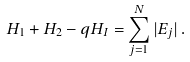Convert formula to latex. <formula><loc_0><loc_0><loc_500><loc_500>H _ { 1 } + H _ { 2 } - q H _ { I } = \sum _ { j = 1 } ^ { N } | E _ { j } | \, .</formula> 